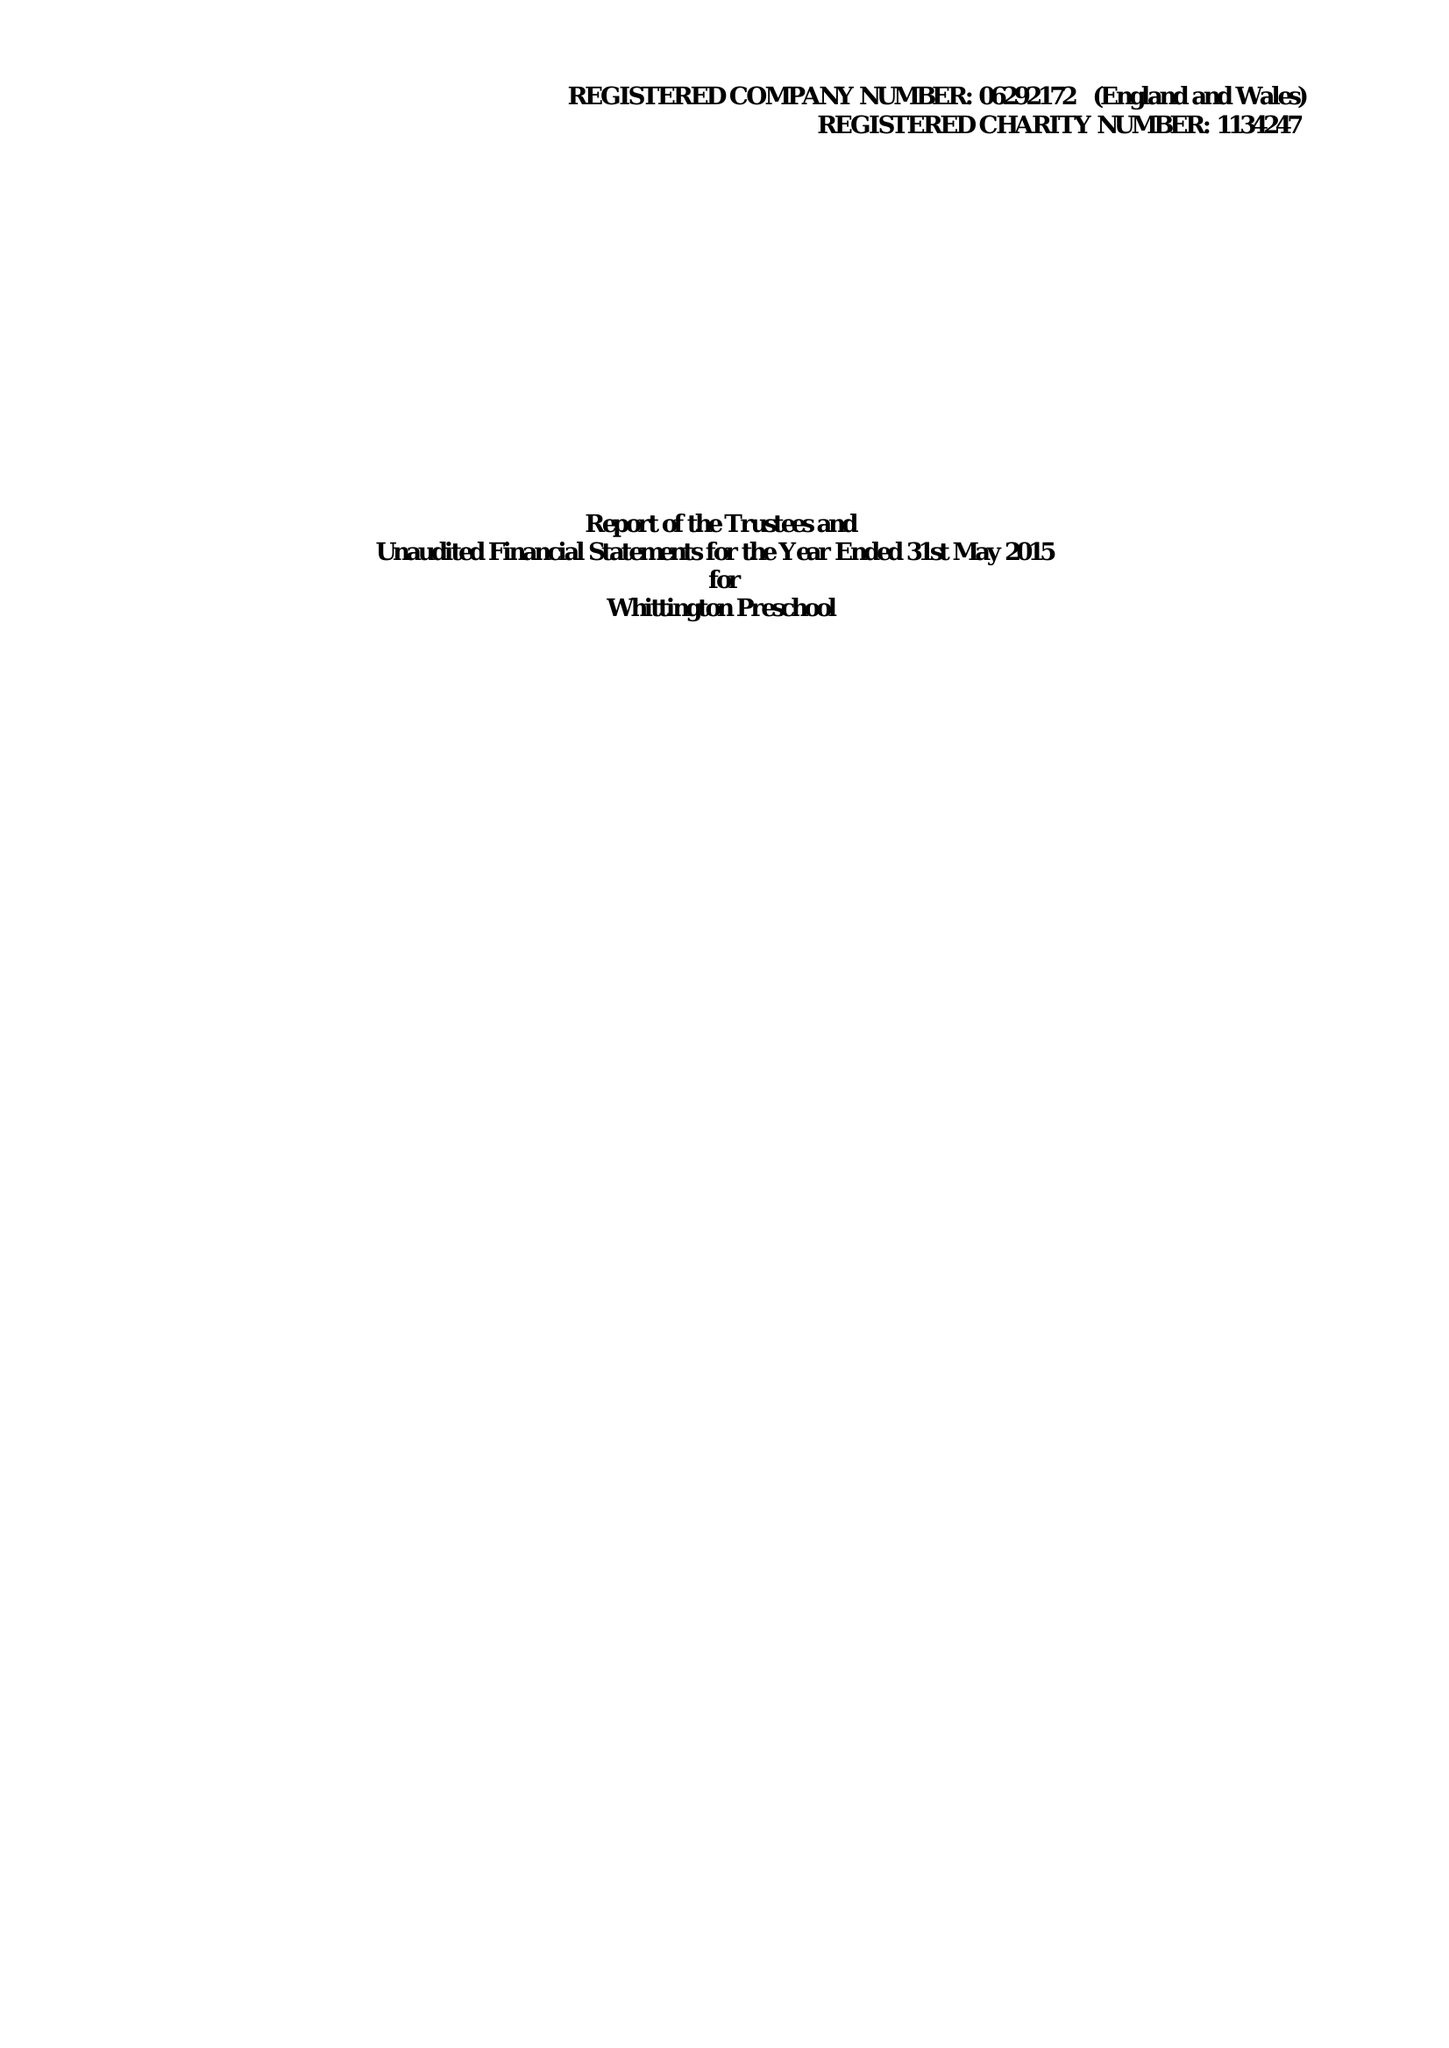What is the value for the address__street_line?
Answer the question using a single word or phrase. WHITTINGTON 